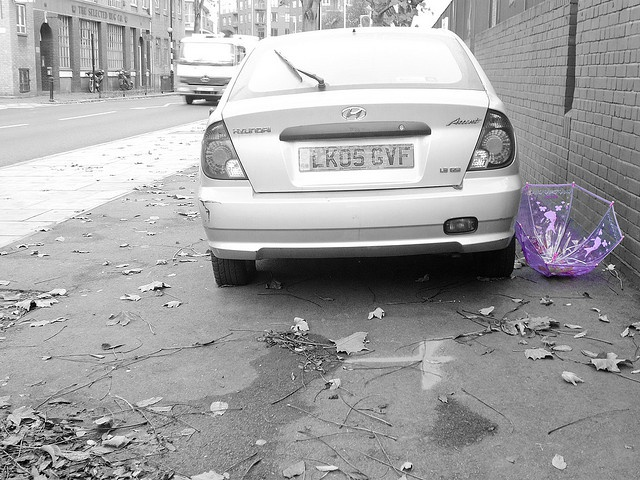Describe the objects in this image and their specific colors. I can see car in silver, lightgray, darkgray, gray, and black tones, umbrella in silver, gray, purple, and violet tones, bus in silver, white, darkgray, gray, and black tones, truck in silver, white, darkgray, gray, and black tones, and bicycle in silver, gray, darkgray, lightgray, and black tones in this image. 